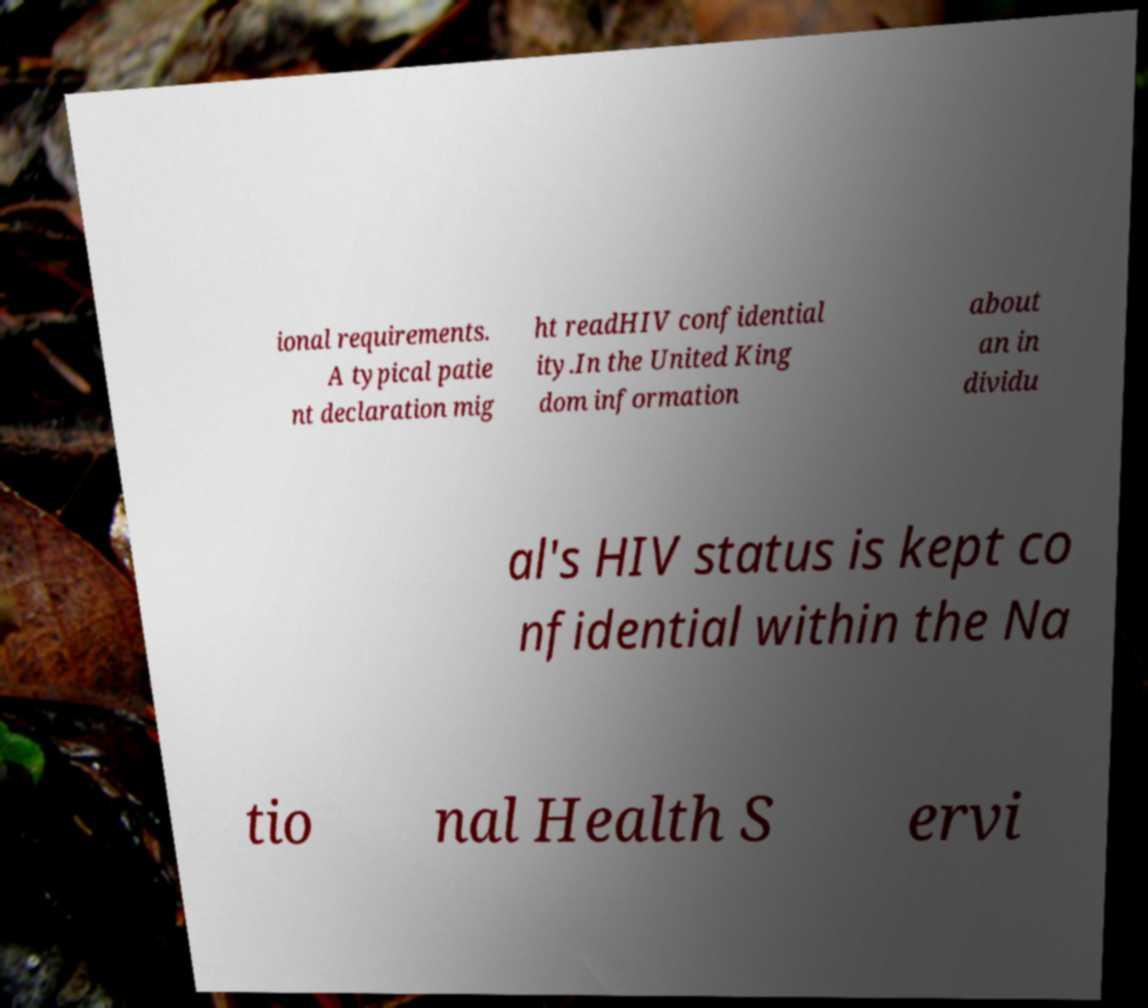There's text embedded in this image that I need extracted. Can you transcribe it verbatim? ional requirements. A typical patie nt declaration mig ht readHIV confidential ity.In the United King dom information about an in dividu al's HIV status is kept co nfidential within the Na tio nal Health S ervi 